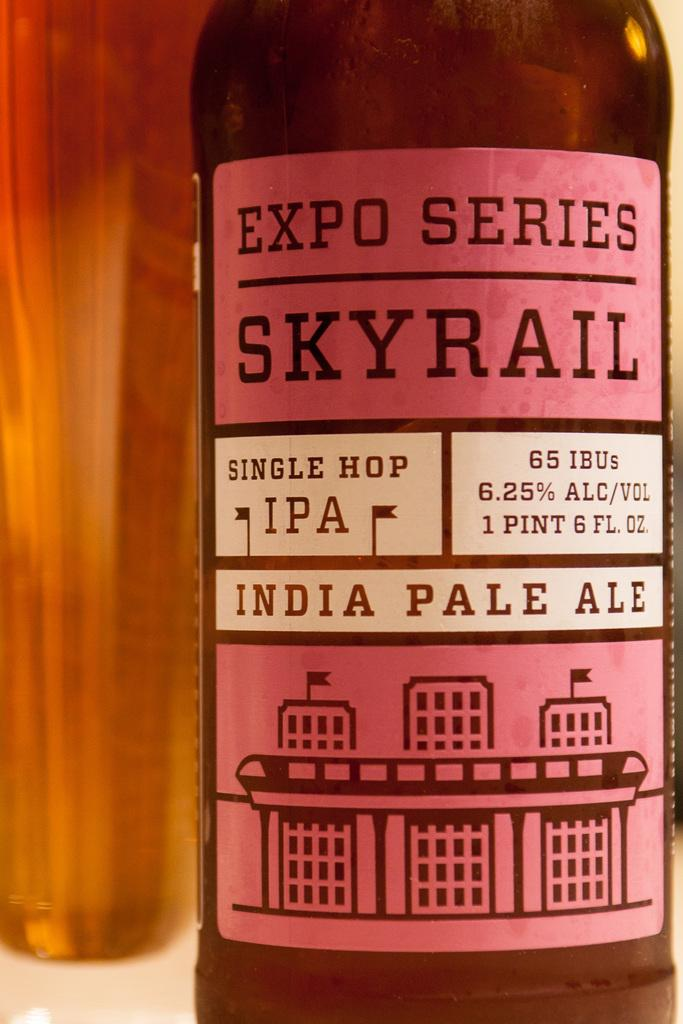<image>
Relay a brief, clear account of the picture shown. A bottle of Skyrail single hop India pale ale. 